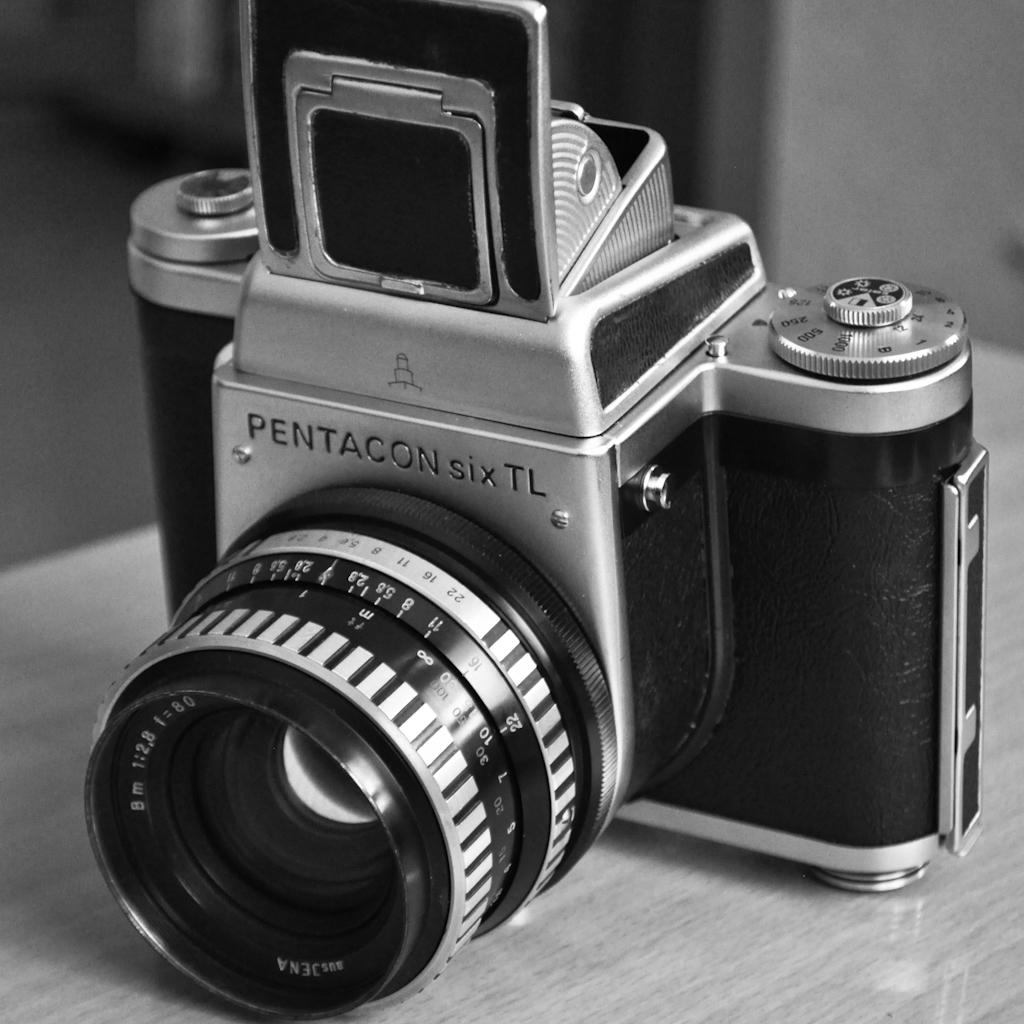What object is the main focus of the image? There is a camera in the image. Can you describe the color be identified on the camera? Yes, the camera has a black and silver color. Is there any text visible on the camera? Yes, there is text written on the camera. What type of holiday is being celebrated in the image? There is no holiday being celebrated in the image; it only features a camera with black and silver color and text written on it. 